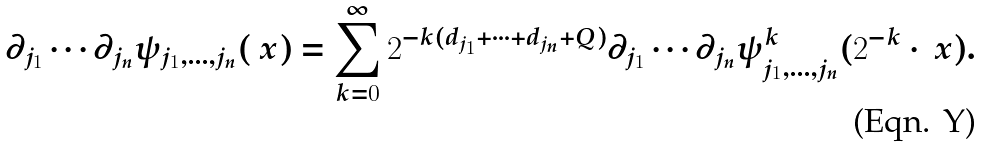Convert formula to latex. <formula><loc_0><loc_0><loc_500><loc_500>\partial _ { j _ { 1 } } \cdots \partial _ { j _ { n } } \psi _ { j _ { 1 } , \dots , j _ { n } } ( \ x ) = \sum _ { k = 0 } ^ { \infty } 2 ^ { - k ( d _ { j _ { 1 } } + \cdots + d _ { j _ { n } } + Q ) } \partial _ { j _ { 1 } } \cdots \partial _ { j _ { n } } \psi _ { j _ { 1 } , \dots , j _ { n } } ^ { k } ( 2 ^ { - k } \cdot \ x ) .</formula> 